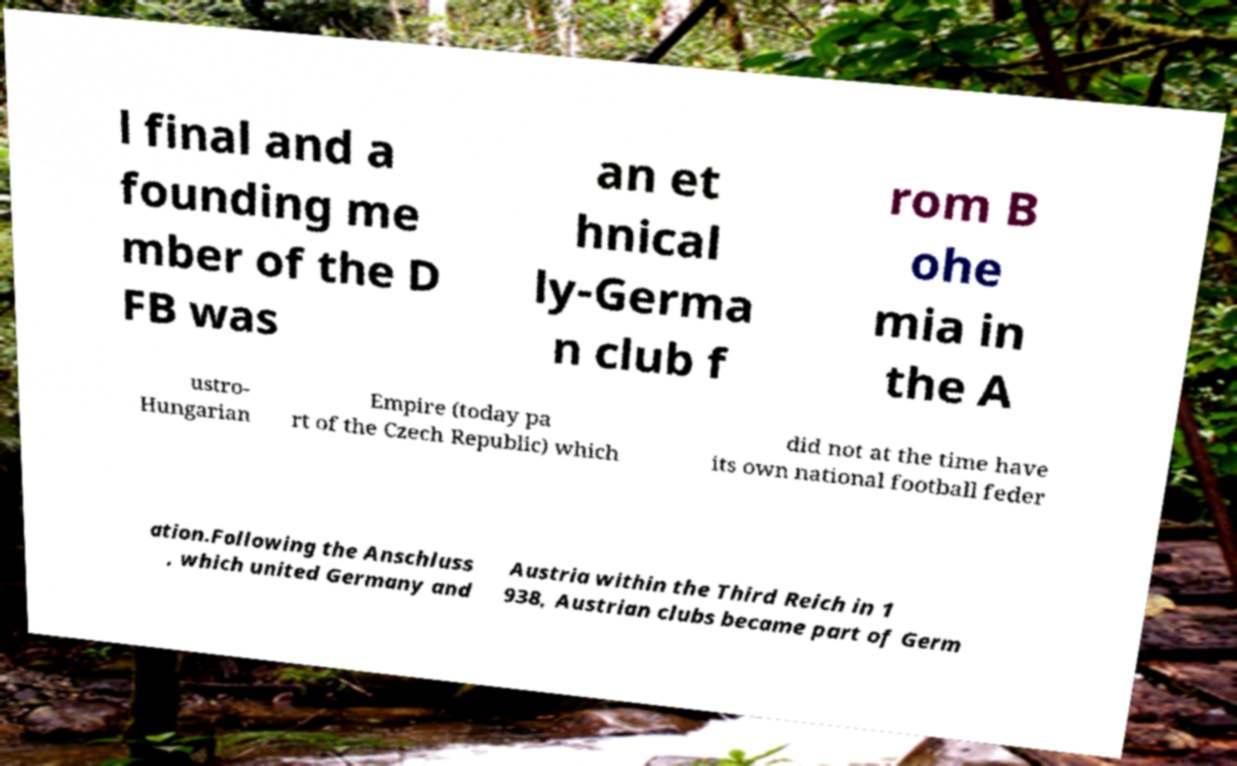What messages or text are displayed in this image? I need them in a readable, typed format. l final and a founding me mber of the D FB was an et hnical ly-Germa n club f rom B ohe mia in the A ustro- Hungarian Empire (today pa rt of the Czech Republic) which did not at the time have its own national football feder ation.Following the Anschluss , which united Germany and Austria within the Third Reich in 1 938, Austrian clubs became part of Germ 